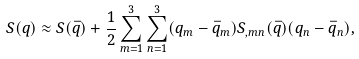<formula> <loc_0><loc_0><loc_500><loc_500>S ( q ) \approx S ( \bar { q } ) + \frac { 1 } { 2 } \sum _ { m = 1 } ^ { 3 } \sum _ { n = 1 } ^ { 3 } ( q _ { m } - \bar { q } _ { m } ) S _ { , m n } ( \bar { q } ) ( q _ { n } - \bar { q } _ { n } ) ,</formula> 